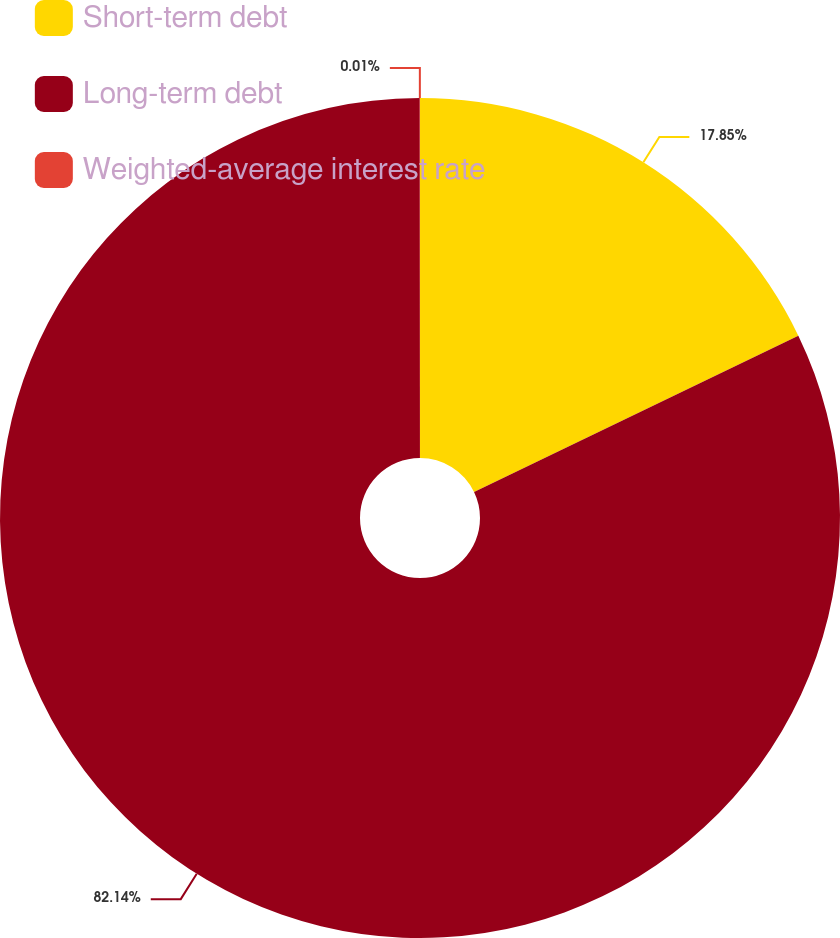Convert chart to OTSL. <chart><loc_0><loc_0><loc_500><loc_500><pie_chart><fcel>Short-term debt<fcel>Long-term debt<fcel>Weighted-average interest rate<nl><fcel>17.85%<fcel>82.13%<fcel>0.01%<nl></chart> 